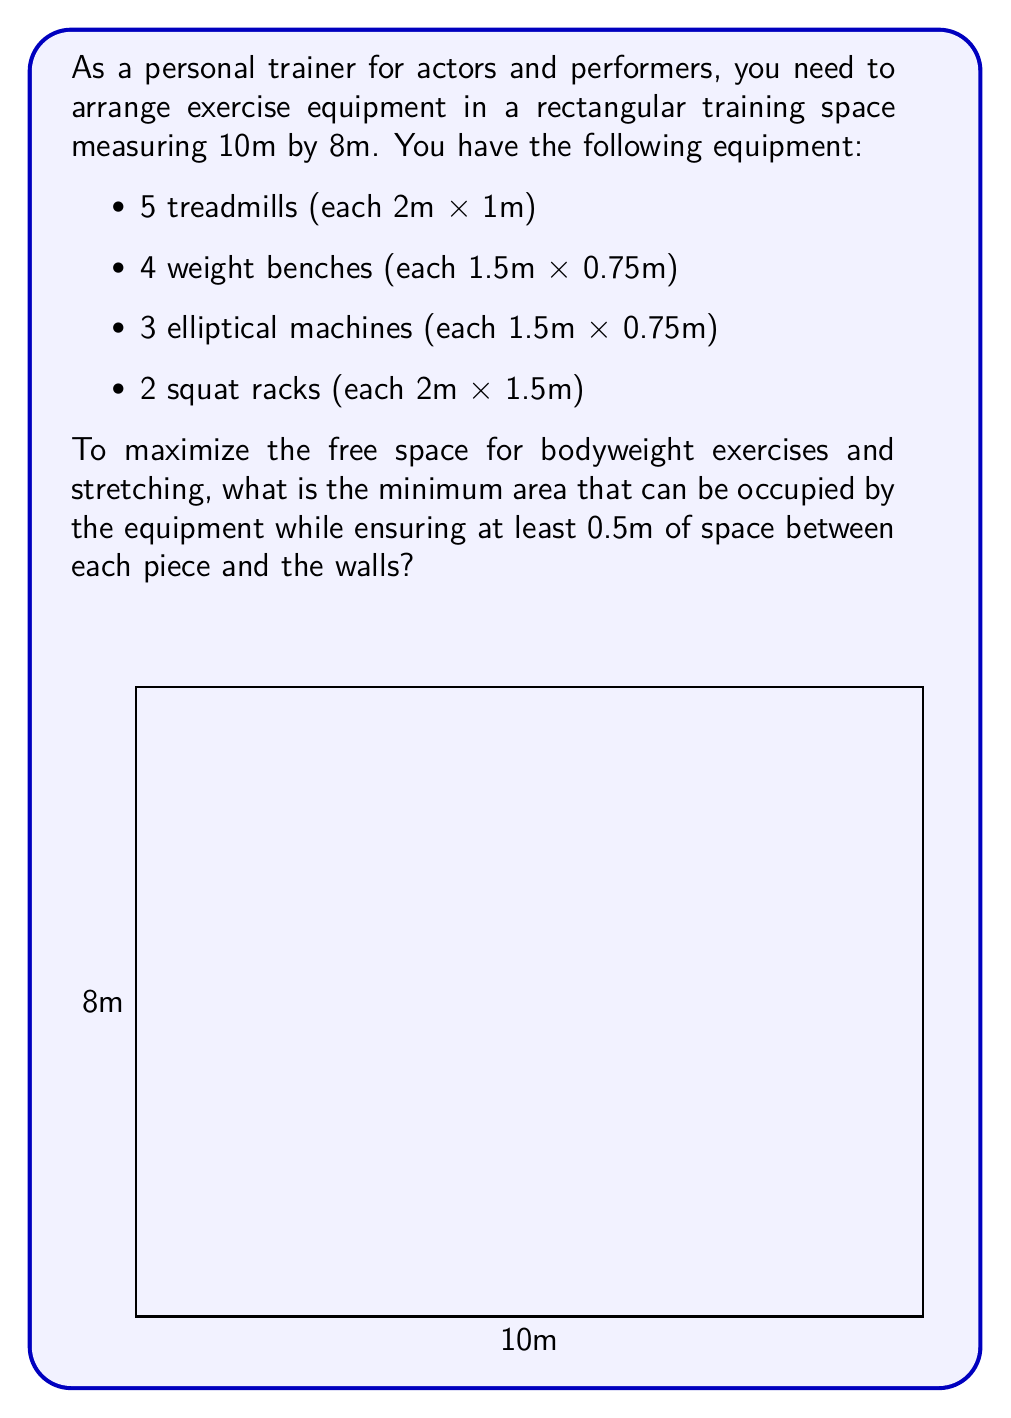What is the answer to this math problem? Let's approach this step-by-step:

1) First, calculate the total area of all equipment:
   $$ A_{total} = 5(2 \times 1) + 4(1.5 \times 0.75) + 3(1.5 \times 0.75) + 2(2 \times 1.5) $$
   $$ = 10 + 4.5 + 3.375 + 6 = 23.875 \text{ m}^2 $$

2) Now, we need to account for the 0.5m space around each piece of equipment. We can do this by adding 1m to each dimension of the equipment:
   - Treadmills: $3\text{m} \times 2\text{m}$
   - Weight benches: $2.5\text{m} \times 1.75\text{m}$
   - Elliptical machines: $2.5\text{m} \times 1.75\text{m}$
   - Squat racks: $3\text{m} \times 2.5\text{m}$

3) Calculate the new total area:
   $$ A_{new} = 5(3 \times 2) + 4(2.5 \times 1.75) + 3(2.5 \times 1.75) + 2(3 \times 2.5) $$
   $$ = 30 + 17.5 + 13.125 + 15 = 75.625 \text{ m}^2 $$

4) However, this area includes overlapping spaces between equipment. The actual minimum area will be less than this.

5) To minimize the area, we can arrange the equipment in a compact manner. One efficient arrangement could be:
   - Place the 5 treadmills in a row (5m x 3m)
   - Stack the 4 weight benches and 3 elliptical machines in two columns (2.5m x 6.125m)
   - Place the 2 squat racks side by side (5.5m x 3m)

6) This arrangement results in a total area of:
   $$ A_{min} = (5 \times 3) + (2.5 \times 6.125) + (5.5 \times 3) $$
   $$ = 15 + 15.3125 + 16.5 = 46.8125 \text{ m}^2 $$

Therefore, the minimum area that can be occupied by the equipment while ensuring the required spacing is approximately 46.81 m².
Answer: 46.81 m² 